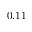Convert formula to latex. <formula><loc_0><loc_0><loc_500><loc_500>0 . 1 1</formula> 